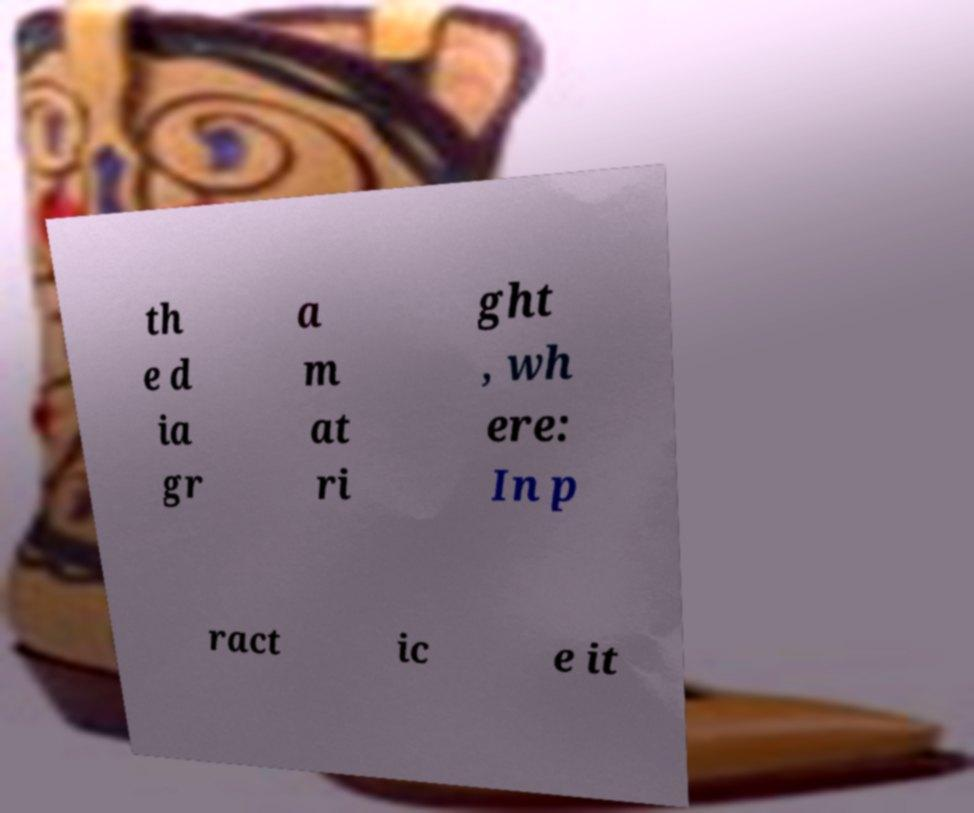Can you accurately transcribe the text from the provided image for me? th e d ia gr a m at ri ght , wh ere: In p ract ic e it 